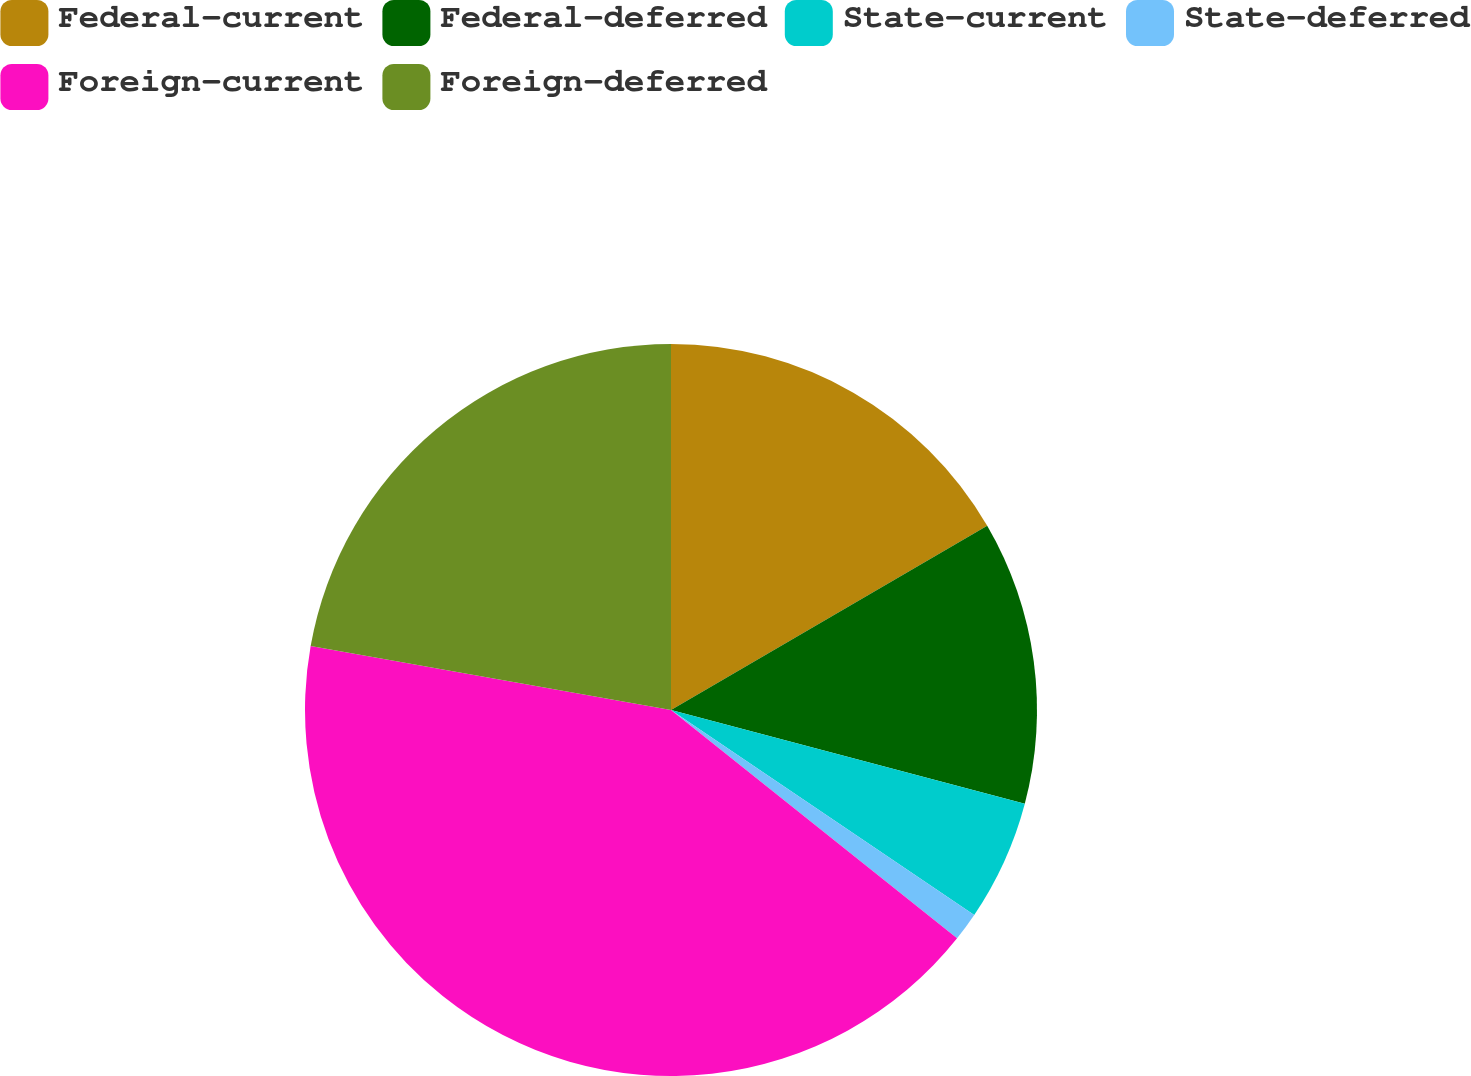<chart> <loc_0><loc_0><loc_500><loc_500><pie_chart><fcel>Federal-current<fcel>Federal-deferred<fcel>State-current<fcel>State-deferred<fcel>Foreign-current<fcel>Foreign-deferred<nl><fcel>16.6%<fcel>12.52%<fcel>5.34%<fcel>1.26%<fcel>42.08%<fcel>22.2%<nl></chart> 